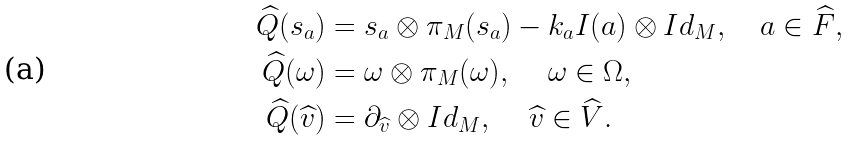Convert formula to latex. <formula><loc_0><loc_0><loc_500><loc_500>\widehat { Q } ( s _ { a } ) & = s _ { a } \otimes \pi _ { M } ( s _ { a } ) - k _ { a } I ( a ) \otimes I d _ { M } , \quad a \in \widehat { F } , \\ \widehat { Q } ( \omega ) & = \omega \otimes \pi _ { M } ( \omega ) , \quad \, \omega \in \Omega , \\ \widehat { Q } ( \widehat { v } ) & = \partial _ { \widehat { v } } \otimes I d _ { M } , \, \quad \widehat { v } \in \widehat { V } .</formula> 